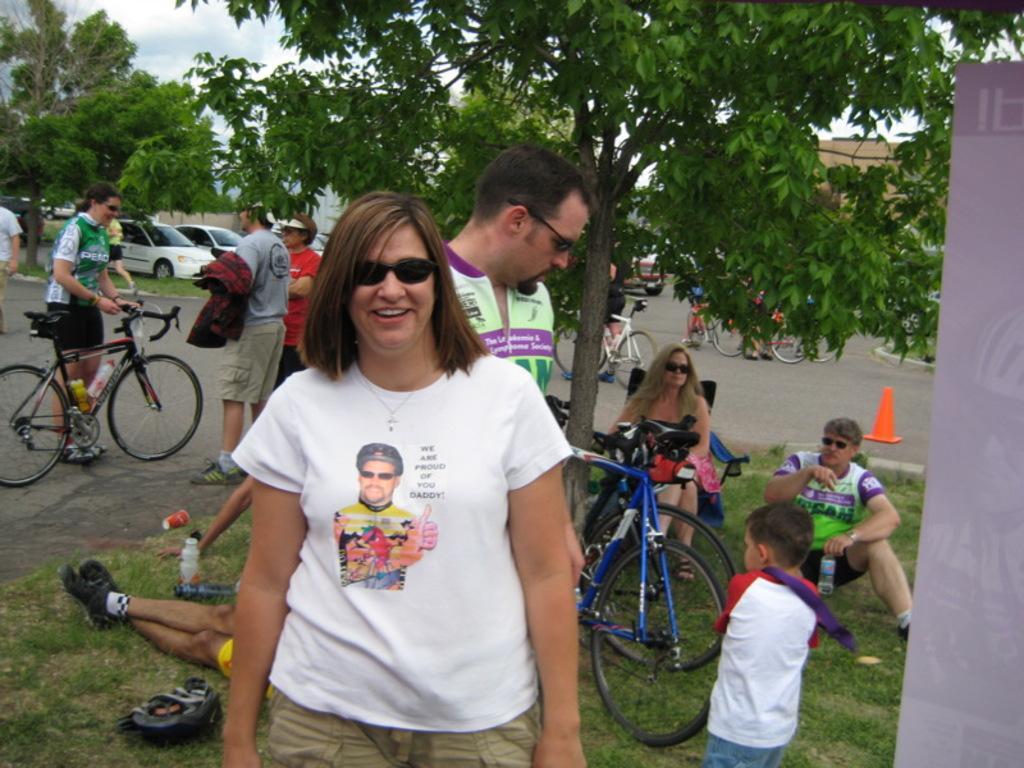How would you summarize this image in a sentence or two? As we can see in the image, there are trees, sky, cars and few people standing on road, bicycle and grass. 